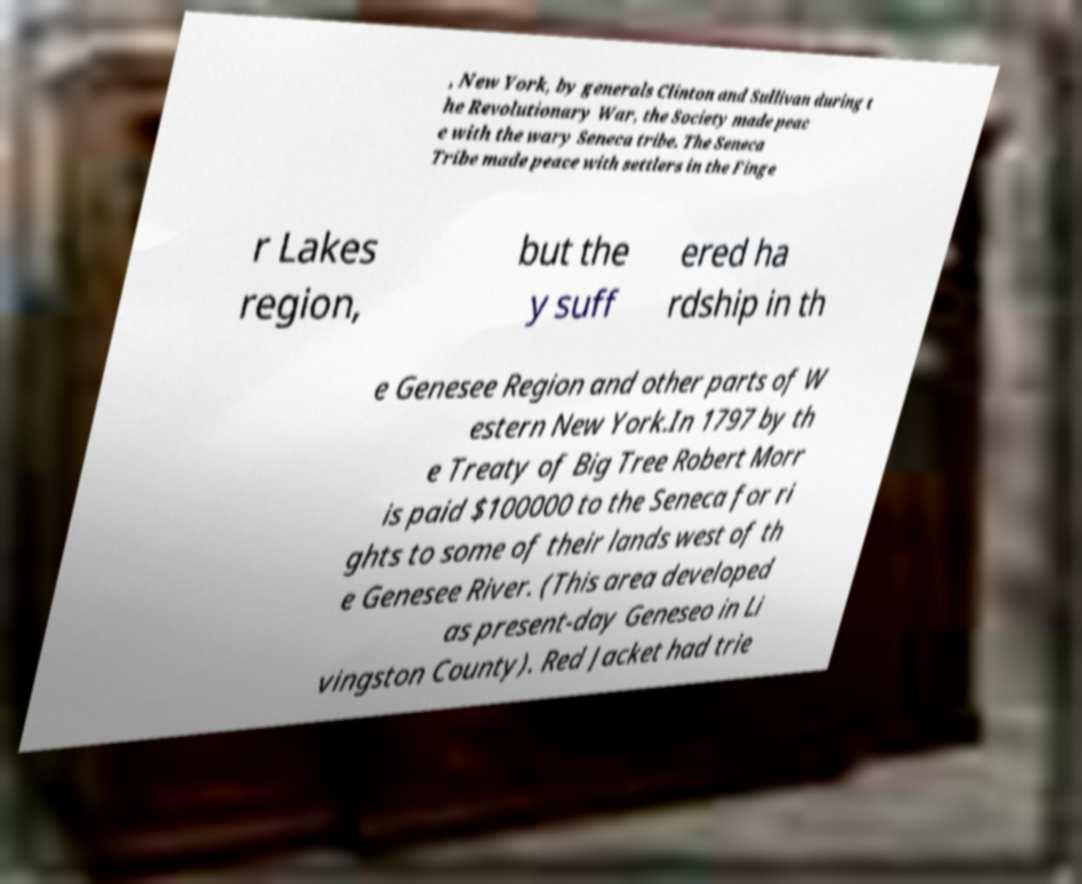What messages or text are displayed in this image? I need them in a readable, typed format. , New York, by generals Clinton and Sullivan during t he Revolutionary War, the Society made peac e with the wary Seneca tribe. The Seneca Tribe made peace with settlers in the Finge r Lakes region, but the y suff ered ha rdship in th e Genesee Region and other parts of W estern New York.In 1797 by th e Treaty of Big Tree Robert Morr is paid $100000 to the Seneca for ri ghts to some of their lands west of th e Genesee River. (This area developed as present-day Geneseo in Li vingston County). Red Jacket had trie 